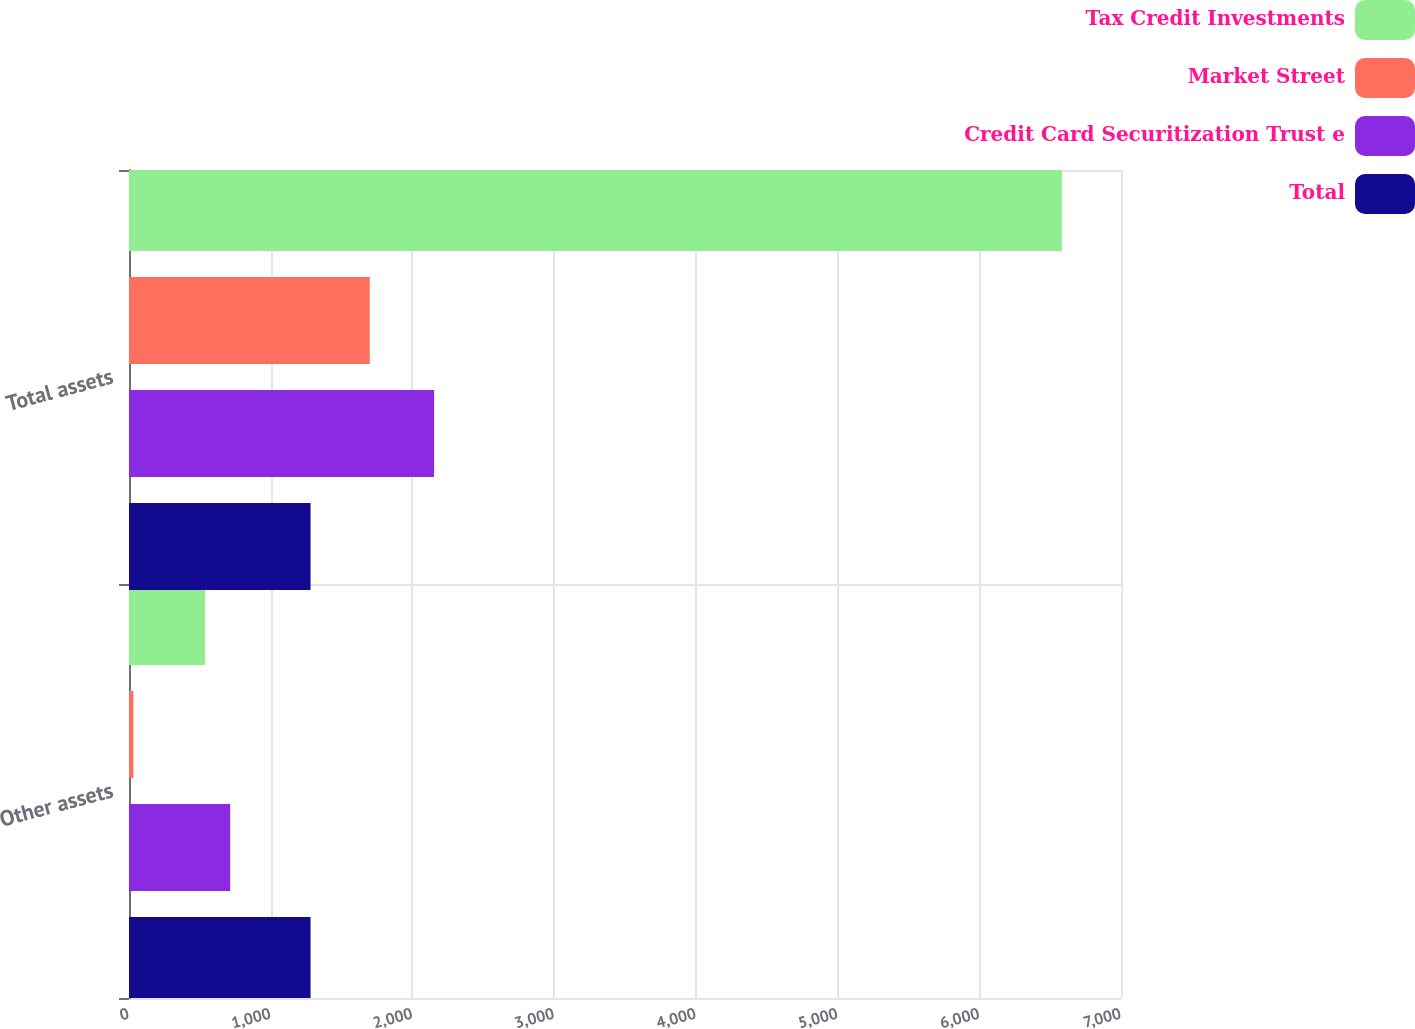Convert chart to OTSL. <chart><loc_0><loc_0><loc_500><loc_500><stacked_bar_chart><ecel><fcel>Other assets<fcel>Total assets<nl><fcel>Tax Credit Investments<fcel>536<fcel>6583<nl><fcel>Market Street<fcel>31<fcel>1699<nl><fcel>Credit Card Securitization Trust e<fcel>714<fcel>2153<nl><fcel>Total<fcel>1281<fcel>1281<nl></chart> 